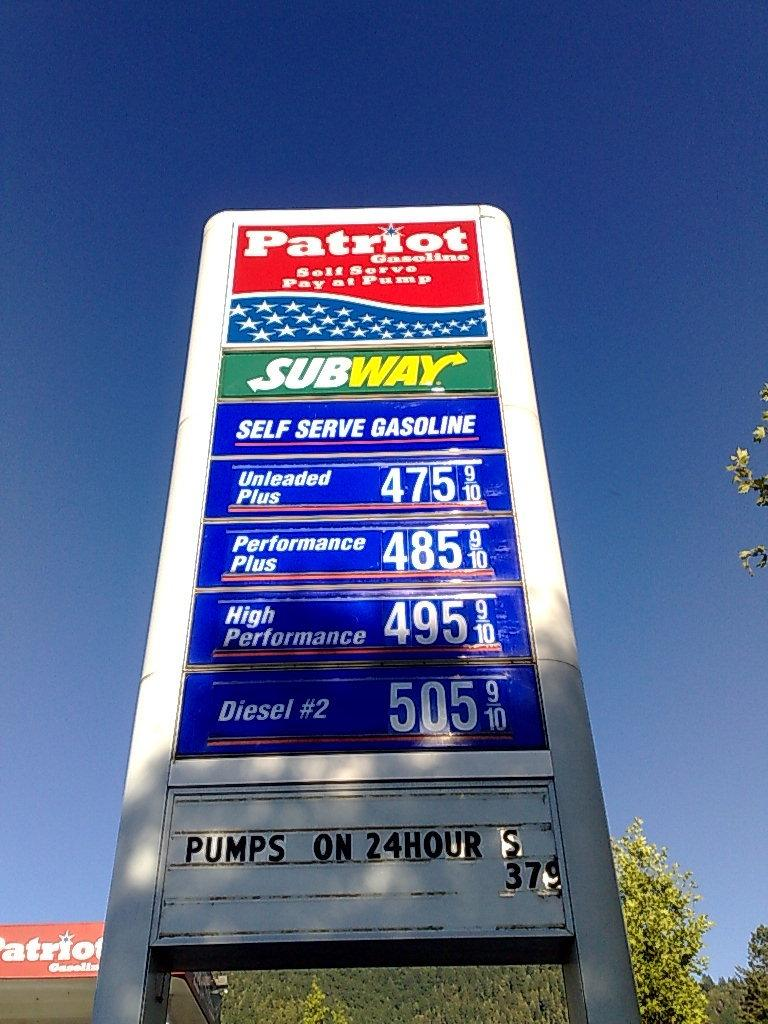<image>
Present a compact description of the photo's key features. Subway food is available at the Patriot gas station. 